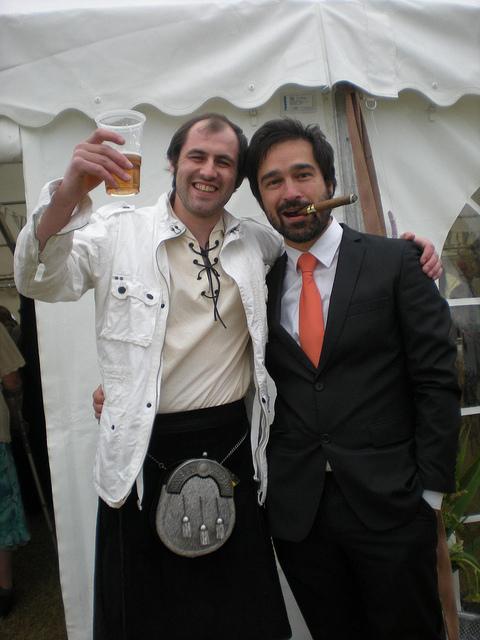What color are the ties?
Answer briefly. Orange. How many medals does the person have?
Quick response, please. 1. What is the celebration for?
Give a very brief answer. Wedding. Which person is smiling with teeth showing?
Be succinct. Left. What is in the man's mouth?
Answer briefly. Cigar. Where is the pink tie?
Keep it brief. Man. What outfit is the man in white wearing?
Be succinct. Costume. 